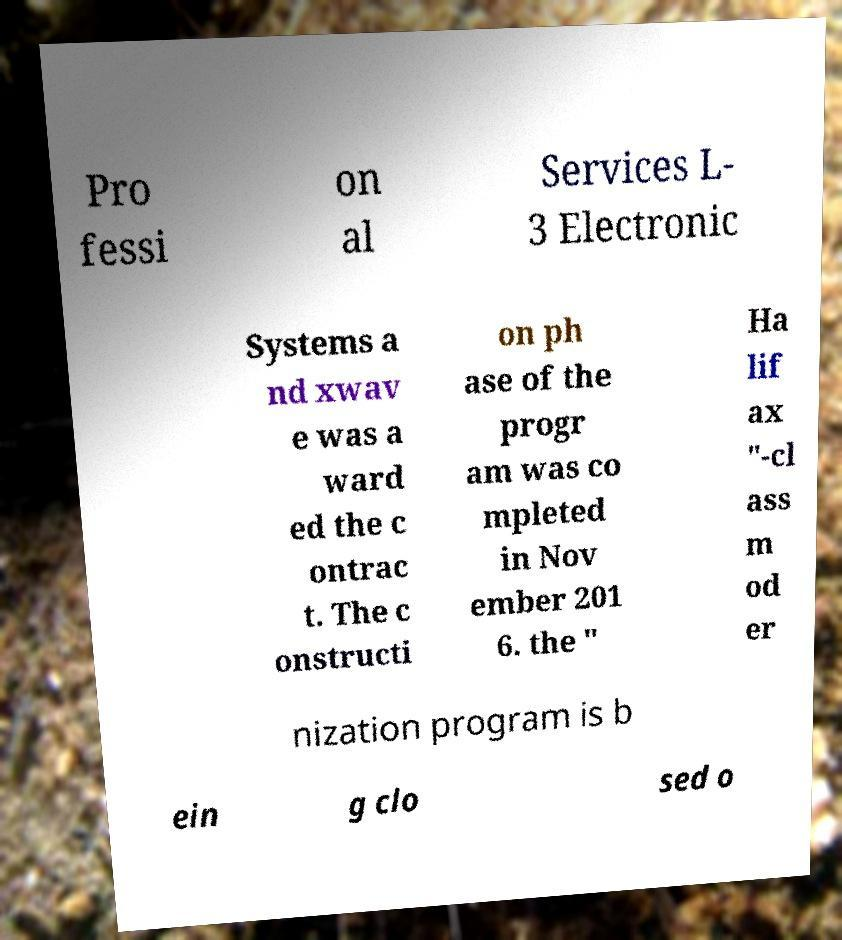Can you accurately transcribe the text from the provided image for me? Pro fessi on al Services L- 3 Electronic Systems a nd xwav e was a ward ed the c ontrac t. The c onstructi on ph ase of the progr am was co mpleted in Nov ember 201 6. the " Ha lif ax "-cl ass m od er nization program is b ein g clo sed o 